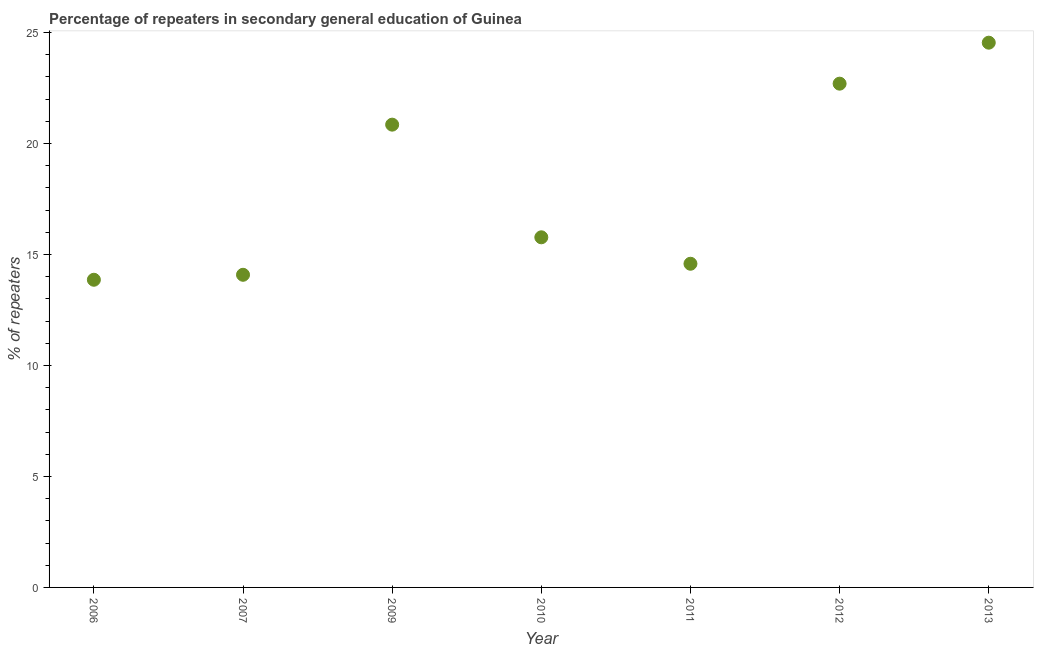What is the percentage of repeaters in 2006?
Your answer should be compact. 13.86. Across all years, what is the maximum percentage of repeaters?
Your answer should be very brief. 24.55. Across all years, what is the minimum percentage of repeaters?
Offer a terse response. 13.86. In which year was the percentage of repeaters maximum?
Offer a very short reply. 2013. What is the sum of the percentage of repeaters?
Ensure brevity in your answer.  126.41. What is the difference between the percentage of repeaters in 2009 and 2011?
Provide a succinct answer. 6.27. What is the average percentage of repeaters per year?
Provide a succinct answer. 18.06. What is the median percentage of repeaters?
Your answer should be very brief. 15.78. What is the ratio of the percentage of repeaters in 2006 to that in 2010?
Keep it short and to the point. 0.88. Is the difference between the percentage of repeaters in 2009 and 2013 greater than the difference between any two years?
Keep it short and to the point. No. What is the difference between the highest and the second highest percentage of repeaters?
Your answer should be very brief. 1.85. What is the difference between the highest and the lowest percentage of repeaters?
Offer a terse response. 10.68. In how many years, is the percentage of repeaters greater than the average percentage of repeaters taken over all years?
Provide a short and direct response. 3. How many dotlines are there?
Make the answer very short. 1. How many years are there in the graph?
Offer a terse response. 7. What is the difference between two consecutive major ticks on the Y-axis?
Your response must be concise. 5. Does the graph contain grids?
Give a very brief answer. No. What is the title of the graph?
Ensure brevity in your answer.  Percentage of repeaters in secondary general education of Guinea. What is the label or title of the X-axis?
Provide a succinct answer. Year. What is the label or title of the Y-axis?
Offer a terse response. % of repeaters. What is the % of repeaters in 2006?
Your response must be concise. 13.86. What is the % of repeaters in 2007?
Offer a very short reply. 14.09. What is the % of repeaters in 2009?
Offer a very short reply. 20.85. What is the % of repeaters in 2010?
Provide a succinct answer. 15.78. What is the % of repeaters in 2011?
Offer a terse response. 14.58. What is the % of repeaters in 2012?
Your answer should be very brief. 22.7. What is the % of repeaters in 2013?
Your answer should be compact. 24.55. What is the difference between the % of repeaters in 2006 and 2007?
Keep it short and to the point. -0.22. What is the difference between the % of repeaters in 2006 and 2009?
Provide a short and direct response. -6.99. What is the difference between the % of repeaters in 2006 and 2010?
Provide a succinct answer. -1.91. What is the difference between the % of repeaters in 2006 and 2011?
Give a very brief answer. -0.72. What is the difference between the % of repeaters in 2006 and 2012?
Keep it short and to the point. -8.84. What is the difference between the % of repeaters in 2006 and 2013?
Your answer should be very brief. -10.68. What is the difference between the % of repeaters in 2007 and 2009?
Provide a short and direct response. -6.77. What is the difference between the % of repeaters in 2007 and 2010?
Offer a terse response. -1.69. What is the difference between the % of repeaters in 2007 and 2011?
Your response must be concise. -0.5. What is the difference between the % of repeaters in 2007 and 2012?
Provide a short and direct response. -8.61. What is the difference between the % of repeaters in 2007 and 2013?
Ensure brevity in your answer.  -10.46. What is the difference between the % of repeaters in 2009 and 2010?
Offer a terse response. 5.08. What is the difference between the % of repeaters in 2009 and 2011?
Offer a very short reply. 6.27. What is the difference between the % of repeaters in 2009 and 2012?
Your response must be concise. -1.85. What is the difference between the % of repeaters in 2009 and 2013?
Your answer should be very brief. -3.69. What is the difference between the % of repeaters in 2010 and 2011?
Give a very brief answer. 1.19. What is the difference between the % of repeaters in 2010 and 2012?
Provide a short and direct response. -6.92. What is the difference between the % of repeaters in 2010 and 2013?
Your answer should be compact. -8.77. What is the difference between the % of repeaters in 2011 and 2012?
Offer a terse response. -8.11. What is the difference between the % of repeaters in 2011 and 2013?
Give a very brief answer. -9.96. What is the difference between the % of repeaters in 2012 and 2013?
Provide a short and direct response. -1.85. What is the ratio of the % of repeaters in 2006 to that in 2007?
Offer a terse response. 0.98. What is the ratio of the % of repeaters in 2006 to that in 2009?
Keep it short and to the point. 0.67. What is the ratio of the % of repeaters in 2006 to that in 2010?
Provide a succinct answer. 0.88. What is the ratio of the % of repeaters in 2006 to that in 2011?
Make the answer very short. 0.95. What is the ratio of the % of repeaters in 2006 to that in 2012?
Offer a very short reply. 0.61. What is the ratio of the % of repeaters in 2006 to that in 2013?
Ensure brevity in your answer.  0.56. What is the ratio of the % of repeaters in 2007 to that in 2009?
Keep it short and to the point. 0.68. What is the ratio of the % of repeaters in 2007 to that in 2010?
Offer a terse response. 0.89. What is the ratio of the % of repeaters in 2007 to that in 2012?
Provide a short and direct response. 0.62. What is the ratio of the % of repeaters in 2007 to that in 2013?
Offer a very short reply. 0.57. What is the ratio of the % of repeaters in 2009 to that in 2010?
Ensure brevity in your answer.  1.32. What is the ratio of the % of repeaters in 2009 to that in 2011?
Your answer should be very brief. 1.43. What is the ratio of the % of repeaters in 2009 to that in 2012?
Your answer should be very brief. 0.92. What is the ratio of the % of repeaters in 2009 to that in 2013?
Provide a short and direct response. 0.85. What is the ratio of the % of repeaters in 2010 to that in 2011?
Offer a very short reply. 1.08. What is the ratio of the % of repeaters in 2010 to that in 2012?
Give a very brief answer. 0.69. What is the ratio of the % of repeaters in 2010 to that in 2013?
Your response must be concise. 0.64. What is the ratio of the % of repeaters in 2011 to that in 2012?
Give a very brief answer. 0.64. What is the ratio of the % of repeaters in 2011 to that in 2013?
Keep it short and to the point. 0.59. What is the ratio of the % of repeaters in 2012 to that in 2013?
Offer a very short reply. 0.93. 